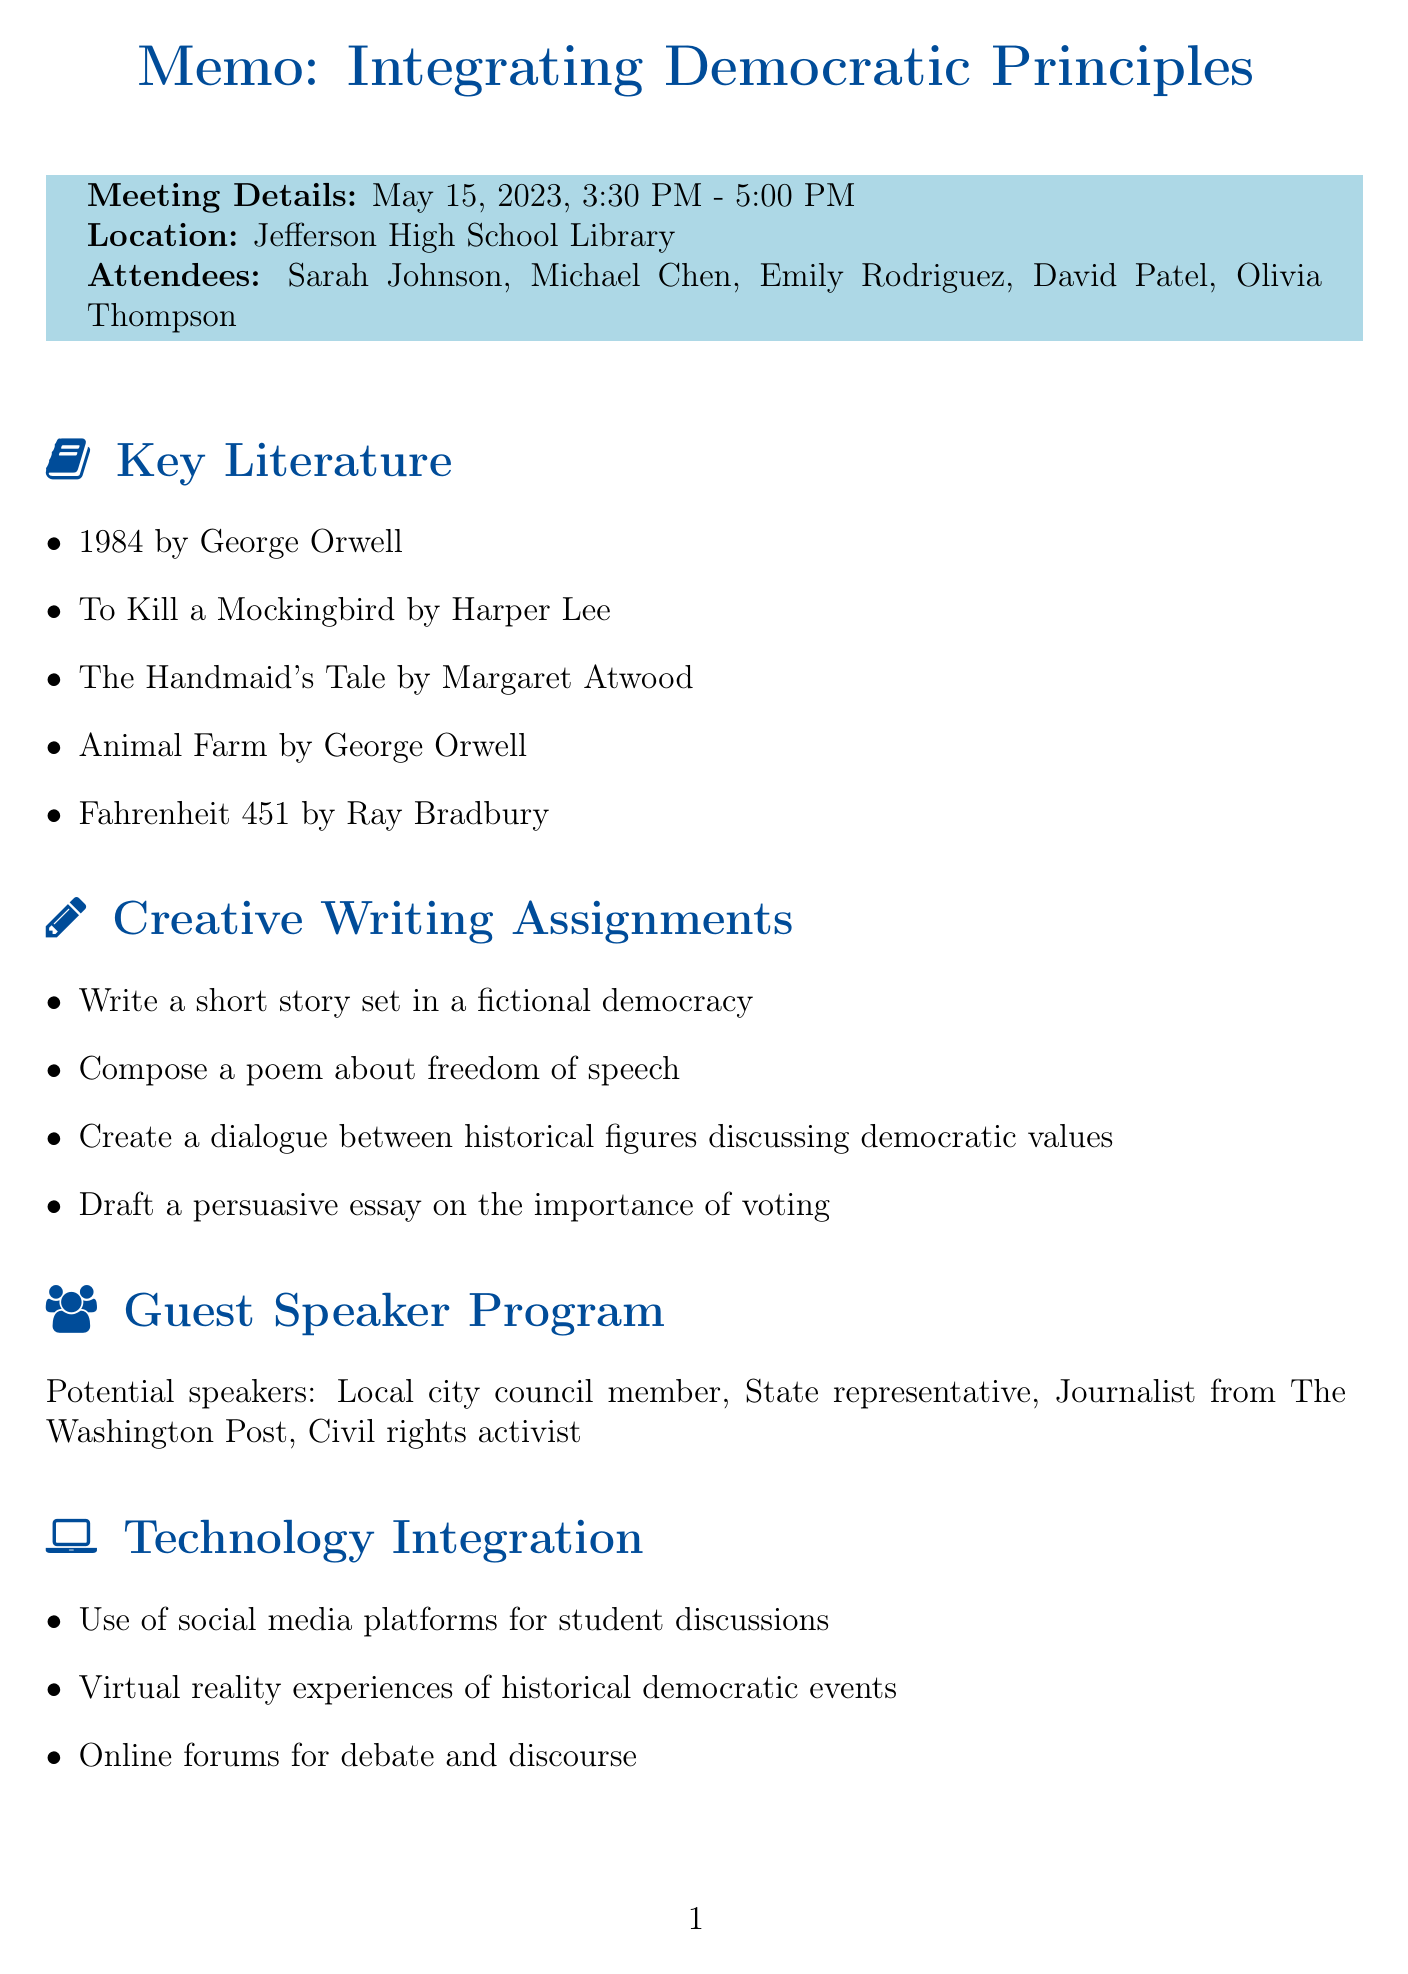What date did the meeting take place? The date of the meeting is explicitly stated in the document as "May 15, 2023".
Answer: May 15, 2023 Who is the English Department Head? The document lists Sarah Johnson as the English Department Head among the attendees.
Answer: Sarah Johnson What is one of the key points discussed regarding democratic principles? The key points highlight the importance of promoting critical thinking and civic engagement as part of integrating democratic principles.
Answer: Promote critical thinking and civic engagement What book by George Orwell was suggested for democratic themes? The document contains two books by George Orwell, one of which is "1984".
Answer: 1984 What is one suggested creative writing assignment? The document outlines multiple creative writing ideas, including writing a short story set in a fictional democracy.
Answer: Write a short story set in a fictional democracy Who is responsible for reaching out to potential guest speakers? According to the action items, Michael is tasked with this responsibility.
Answer: Michael How long will the next meeting last? The duration of the next meeting is stated to be from 3:30 PM, but its end time isn't specified, making it unclear. Given the previous meeting, it's likely it will also be 1.5 hours.
Answer: 1.5 hours What technology tool is suggested for student discussions? The document mentions the use of social media platforms as a tool for this purpose.
Answer: Social media platforms What is one method for assessing students' democratic understanding? The document provides various assessment strategies, including portfolio-based assessment.
Answer: Portfolio-based assessment 